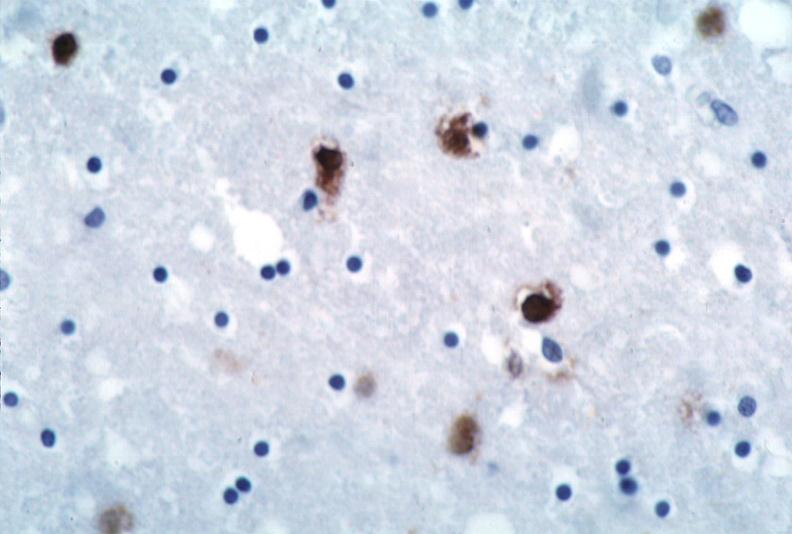what does this image show?
Answer the question using a single word or phrase. Brain 